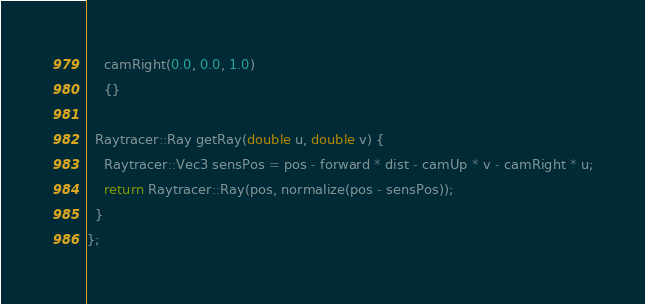Convert code to text. <code><loc_0><loc_0><loc_500><loc_500><_C++_>    camRight(0.0, 0.0, 1.0)
    {}
  
  Raytracer::Ray getRay(double u, double v) {
    Raytracer::Vec3 sensPos = pos - forward * dist - camUp * v - camRight * u;
    return Raytracer::Ray(pos, normalize(pos - sensPos));
  }
};
</code> 